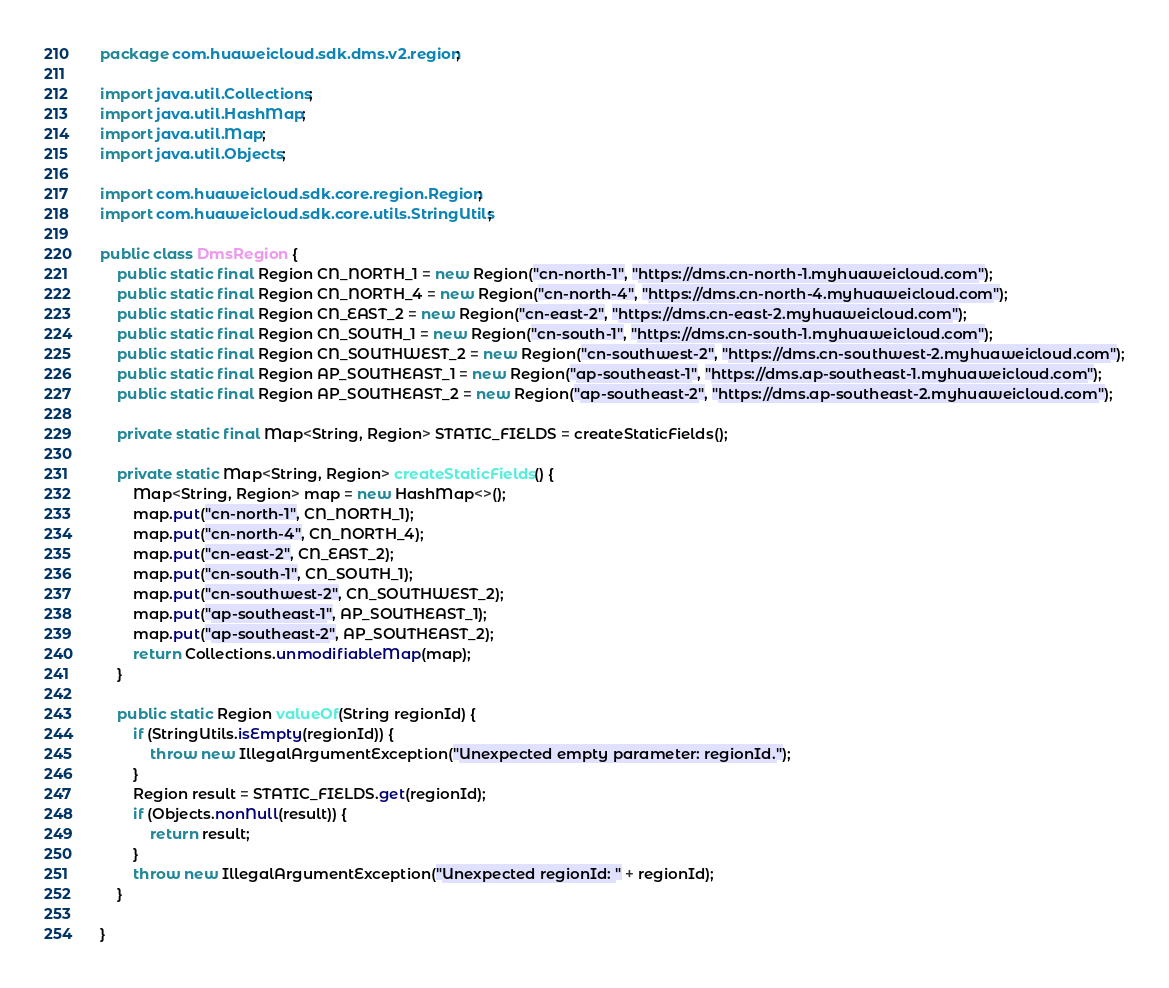Convert code to text. <code><loc_0><loc_0><loc_500><loc_500><_Java_>package com.huaweicloud.sdk.dms.v2.region;

import java.util.Collections;
import java.util.HashMap;
import java.util.Map;
import java.util.Objects;

import com.huaweicloud.sdk.core.region.Region;
import com.huaweicloud.sdk.core.utils.StringUtils;

public class DmsRegion {
    public static final Region CN_NORTH_1 = new Region("cn-north-1", "https://dms.cn-north-1.myhuaweicloud.com");
    public static final Region CN_NORTH_4 = new Region("cn-north-4", "https://dms.cn-north-4.myhuaweicloud.com");
    public static final Region CN_EAST_2 = new Region("cn-east-2", "https://dms.cn-east-2.myhuaweicloud.com");
    public static final Region CN_SOUTH_1 = new Region("cn-south-1", "https://dms.cn-south-1.myhuaweicloud.com");
    public static final Region CN_SOUTHWEST_2 = new Region("cn-southwest-2", "https://dms.cn-southwest-2.myhuaweicloud.com");
    public static final Region AP_SOUTHEAST_1 = new Region("ap-southeast-1", "https://dms.ap-southeast-1.myhuaweicloud.com");
    public static final Region AP_SOUTHEAST_2 = new Region("ap-southeast-2", "https://dms.ap-southeast-2.myhuaweicloud.com");
    
    private static final Map<String, Region> STATIC_FIELDS = createStaticFields();

    private static Map<String, Region> createStaticFields() {
        Map<String, Region> map = new HashMap<>();
        map.put("cn-north-1", CN_NORTH_1);
        map.put("cn-north-4", CN_NORTH_4);
        map.put("cn-east-2", CN_EAST_2);
        map.put("cn-south-1", CN_SOUTH_1);
        map.put("cn-southwest-2", CN_SOUTHWEST_2);
        map.put("ap-southeast-1", AP_SOUTHEAST_1);
        map.put("ap-southeast-2", AP_SOUTHEAST_2);
        return Collections.unmodifiableMap(map);
    }

    public static Region valueOf(String regionId) {
        if (StringUtils.isEmpty(regionId)) {
            throw new IllegalArgumentException("Unexpected empty parameter: regionId.");
        }
        Region result = STATIC_FIELDS.get(regionId);
        if (Objects.nonNull(result)) {
            return result;
        }
        throw new IllegalArgumentException("Unexpected regionId: " + regionId);
    }

}
</code> 